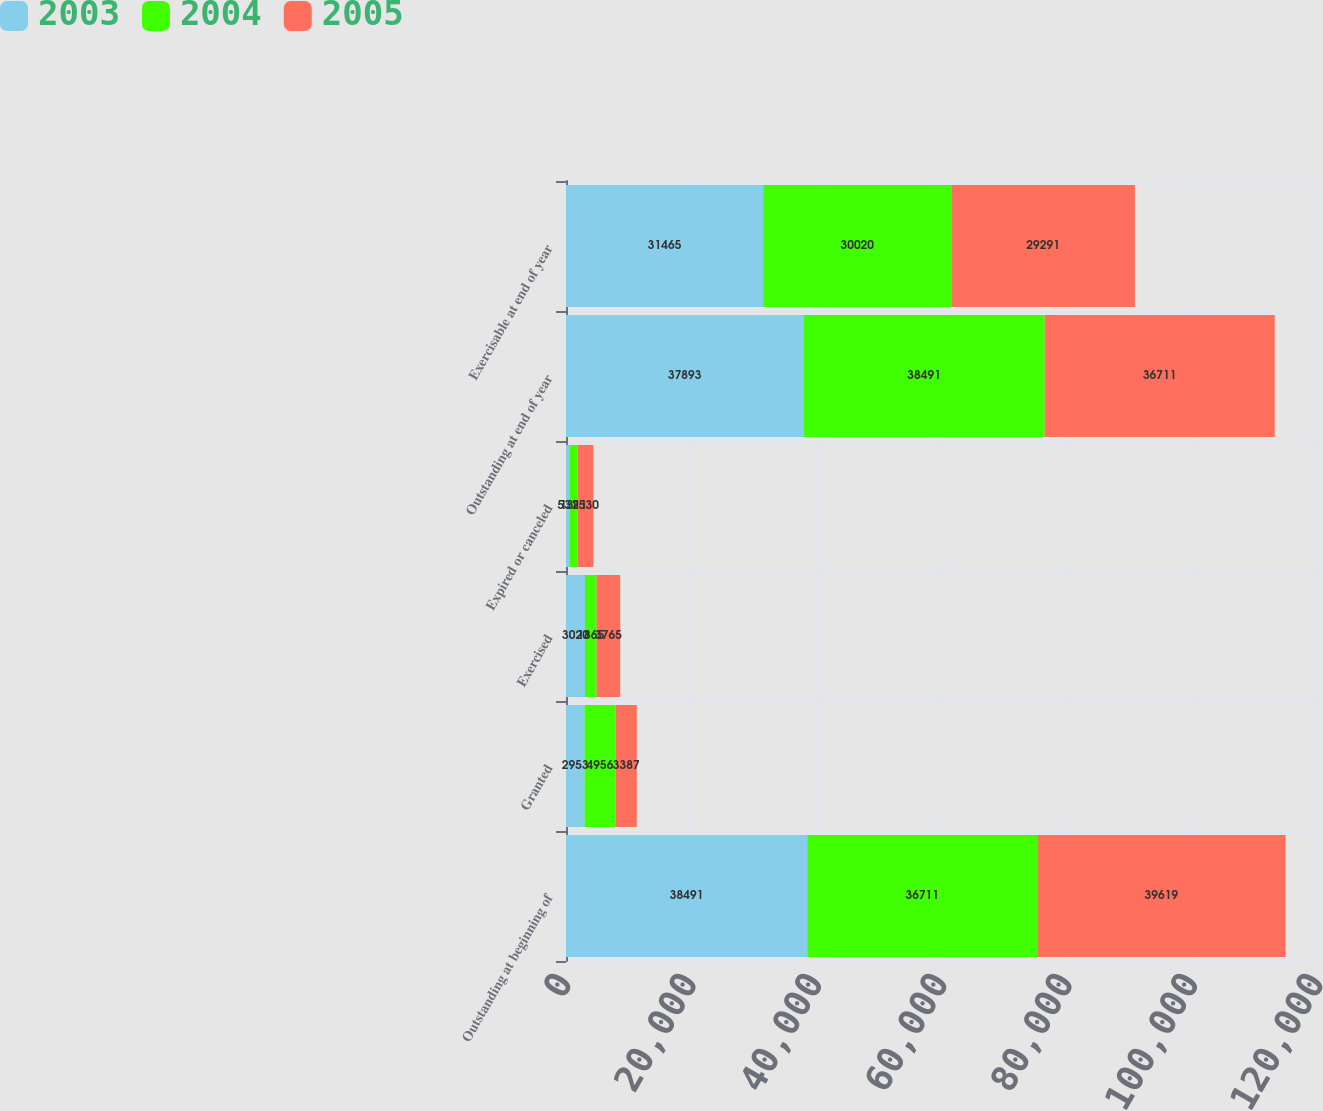Convert chart to OTSL. <chart><loc_0><loc_0><loc_500><loc_500><stacked_bar_chart><ecel><fcel>Outstanding at beginning of<fcel>Granted<fcel>Exercised<fcel>Expired or canceled<fcel>Outstanding at end of year<fcel>Exercisable at end of year<nl><fcel>2003<fcel>38491<fcel>2953<fcel>3020<fcel>531<fcel>37893<fcel>31465<nl><fcel>2004<fcel>36711<fcel>4956<fcel>1865<fcel>1311<fcel>38491<fcel>30020<nl><fcel>2005<fcel>39619<fcel>3387<fcel>3765<fcel>2530<fcel>36711<fcel>29291<nl></chart> 